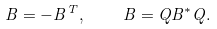<formula> <loc_0><loc_0><loc_500><loc_500>B = - B ^ { T } , \quad B = Q B ^ { * } Q .</formula> 